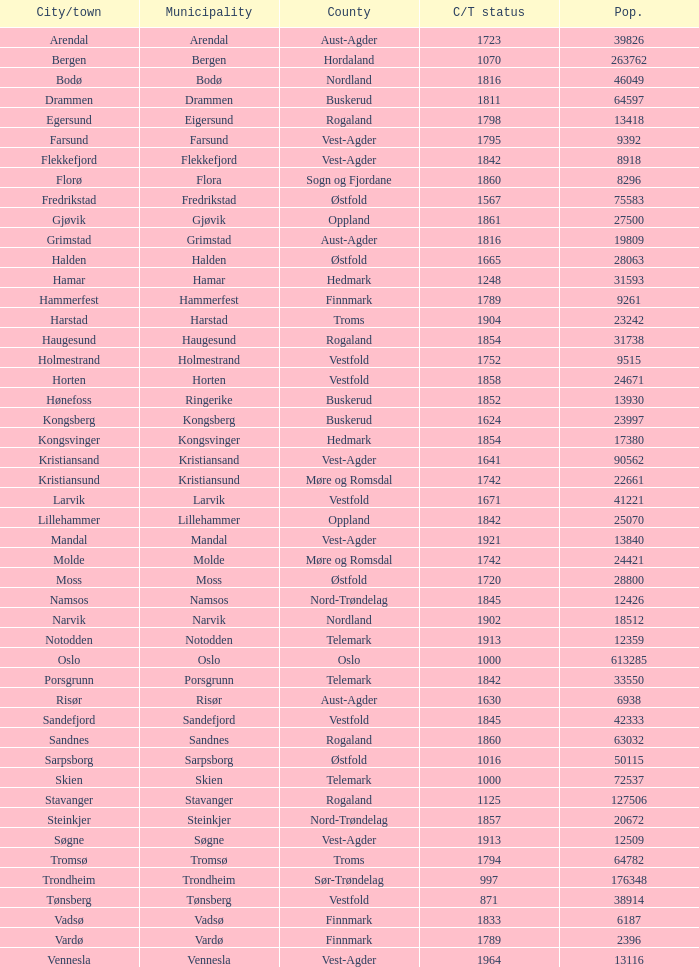In which county is the city/town of Halden located? Østfold. 